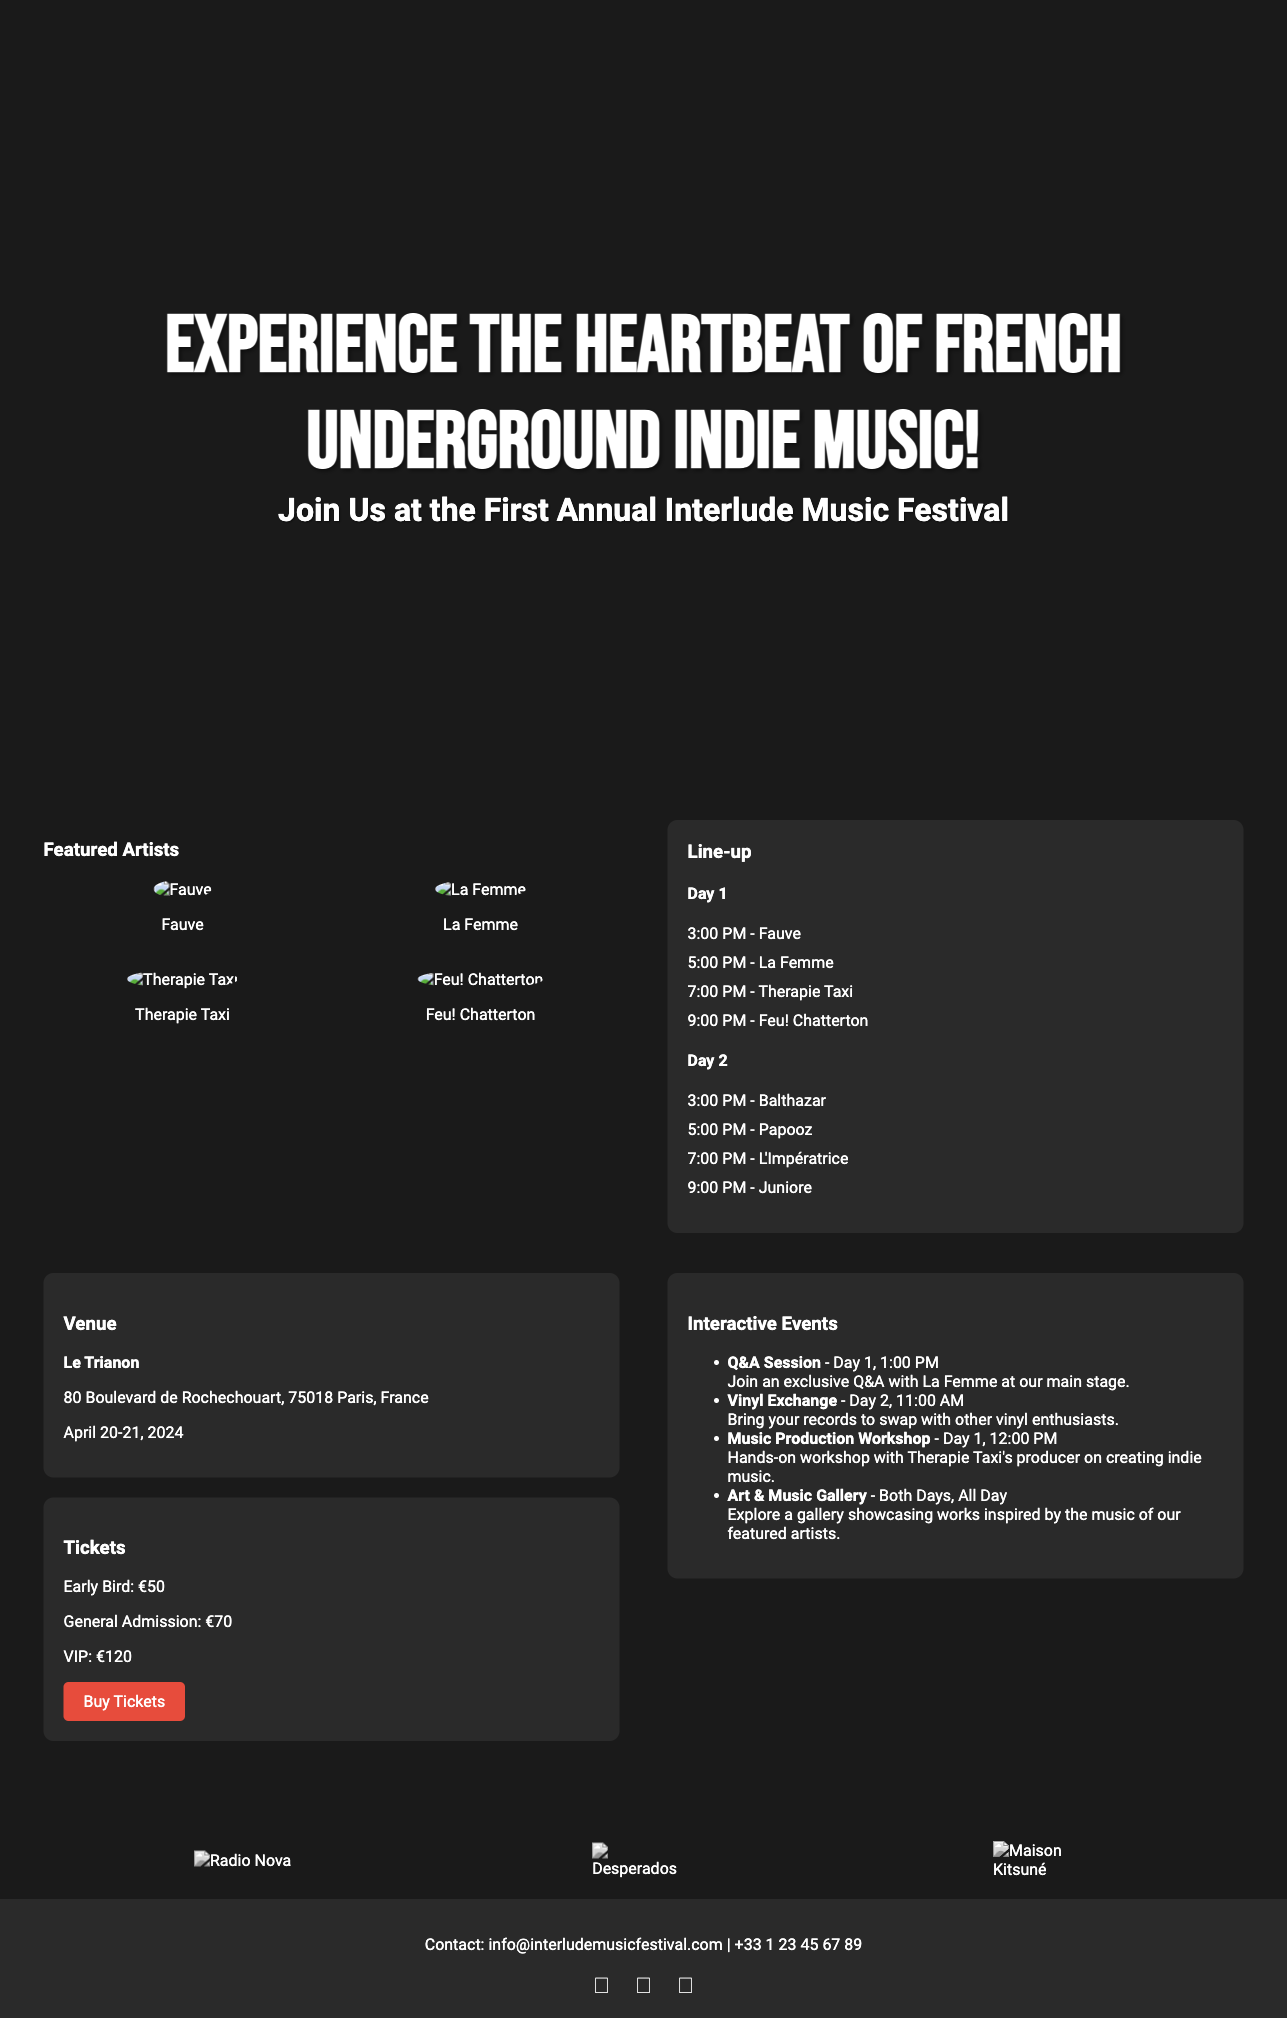What is the name of the festival? The name of the festival is prominently displayed in the header of the advertisement.
Answer: Interlude Music Festival Where is the festival taking place? The venue information is included in the advertisement under the venue section.
Answer: Le Trianon What are the dates of the festival? The dates are specifically mentioned in the venue section of the document.
Answer: April 20-21, 2024 How much does a VIP ticket cost? The ticket prices are clearly listed in the tickets section.
Answer: €120 Which artist is performing at 5:00 PM on Day 1? The lineup section details the times and artists performing each day.
Answer: La Femme What type of interactive event is hosted at noon on Day 1? The interactive events section specifies the schedule of activities available.
Answer: Music Production Workshop How many artists are featured in the lineup for Day 1? The lineup section lists the number of artists performing across the two days.
Answer: 4 Which sponsor is featured first in the advertisement? The sponsors section shows the logos in a horizontal line where the first logo appears first.
Answer: Radio Nova What is the email contact for the festival? Contact information is provided at the bottom of the advertisement in the footer.
Answer: info@interludemusicfestival.com 